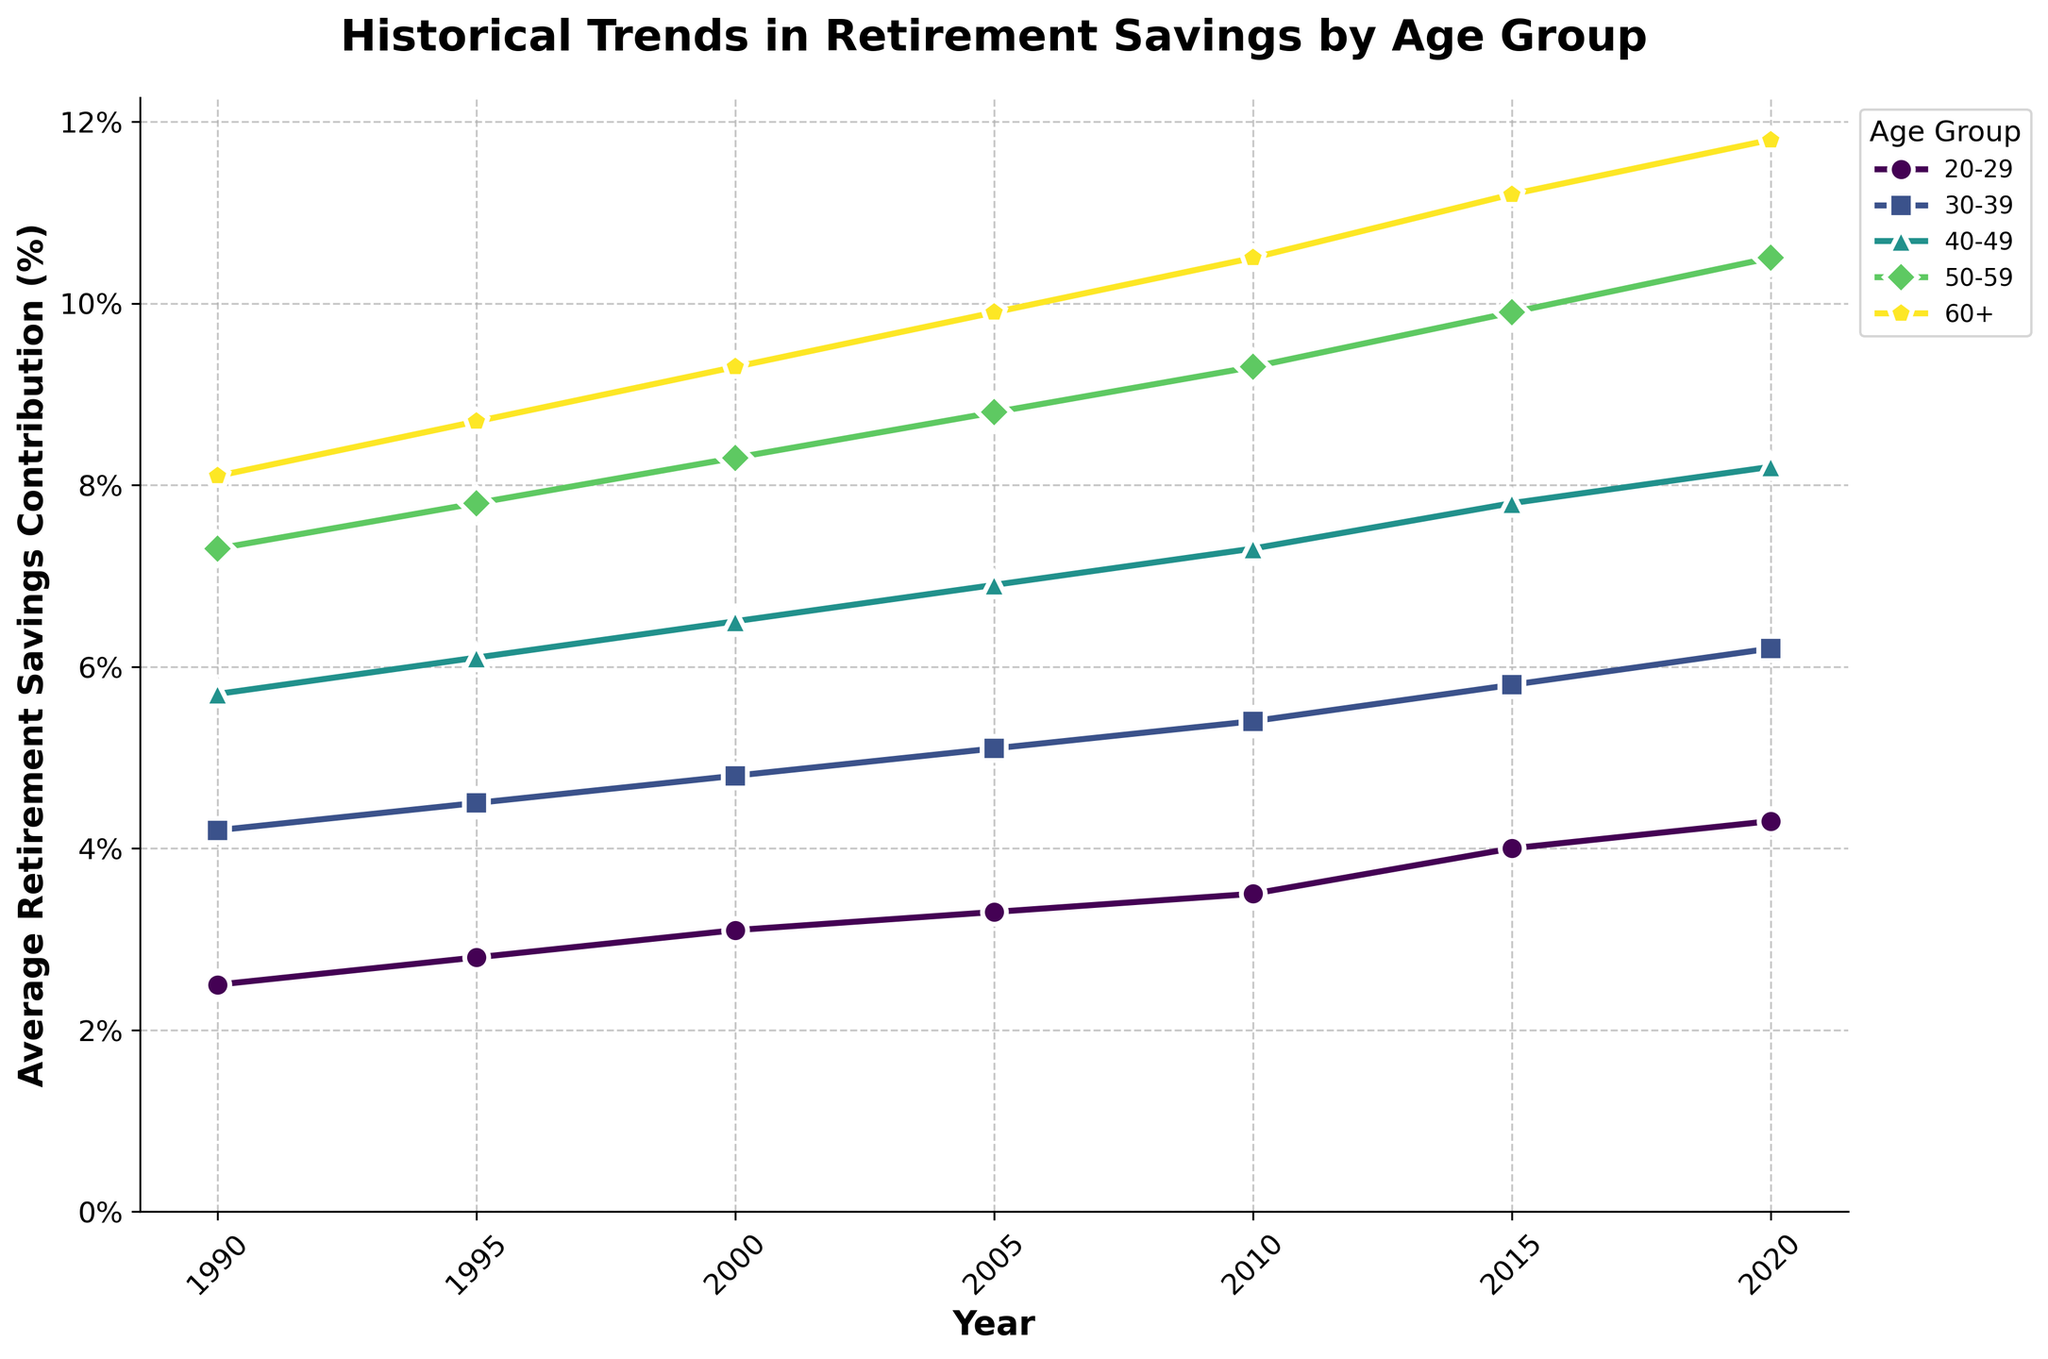What is the trend in average retirement savings contributions for the 40-49 age group between 1990 and 2020? The line plot for the 40-49 age group shows an upward trend. Starting from 5.7% in 1990, the contributions increase steadily to 8.2% by 2020.
Answer: Upward trend Which age group had the highest average retirement savings contributions in 2010? According to the line plot, the 60+ age group had the highest contribution in 2010, with a rate of 10.5%.
Answer: 60+ By how much did the average retirement savings contributions increase for the 30-39 age group between 1990 and 2000? The contributions for the 30-39 age group were 4.2% in 1990 and 4.8% in 2000. The increase is 4.8% - 4.2% = 0.6%.
Answer: 0.6% Which age group showed the most significant percentage increase in contributions from 1990 to 2020? The percentage increase can be calculated for each age group. The 60+ group increased from 8.1% to 11.8%, a difference of 3.7%. The 50-59 group increased from 7.3% to 10.5%, a difference of 3.2%. The 40-49 group increased from 5.7% to 8.2%, a difference of 2.5%. The 30-39 group increased from 4.2% to 6.2%, a difference of 2.0%. The 20-29 group increased from 2.5% to 4.3%, a difference of 1.8%. The 60+ group had the highest increase of 3.7%.
Answer: 60+ How do the contributions for the 20-29 age group in 2020 compare to those for the 30-39 age group in 2000? The contributions for the 20-29 age group in 2020 are 4.3%. The contributions for the 30-39 age group in 2000 are 4.8%. Therefore, the contributions for the 20-29 age group in 2020 are slightly lower than those for the 30-39 age group in 2000.
Answer: Slightly lower What is the average increase in retirement savings contributions per decade for the 50-59 age group? Calculate the increases for each decade: 7.8%-7.3%=0.5% (1990-1995), 8.3%-7.8%=0.5% (1995-2000), 8.8%-8.3%=0.5% (2000-2005), 9.3%-8.8%=0.5% (2005-2010), 9.9%-9.3%=0.6% (2010-2015), 10.5%-9.9%=0.6% (2015-2020). The average increase per decade is (0.5%+0.5%+0.5%+0.5%+0.6%+0.6%)/6 = 0.533%, rounded to 0.53%.
Answer: 0.53% Who had higher average retirement savings contributions in 1995, the 40-49 age group or the 50-59 age group? In 1995, the contributions for the 40-49 age group were 6.1% and for the 50-59 age group, they were 7.8%. Therefore, the 50-59 age group had higher contributions.
Answer: 50-59 age group What is the difference in contribution rates between the youngest and oldest age groups in 2020? In 2020, the youngest age group (20-29) contributed 4.3%, and the oldest age group (60+) contributed 11.8%. The difference is 11.8% - 4.3% = 7.5%.
Answer: 7.5% Which age group's contributions saw the most significant rise between 1990 and 2000? Calculate the rise for each age group between 1990 and 2000: 20-29: 3.1%-2.5%=0.6%, 30-39: 4.8%-4.2%=0.6%, 40-49: 6.5%-5.7%=0.8%, 50-59: 8.3%-7.3%=1.0%, 60+: 9.3%-8.1%=1.2%. The 60+ age group saw the most significant rise of 1.2%.
Answer: 60+ 